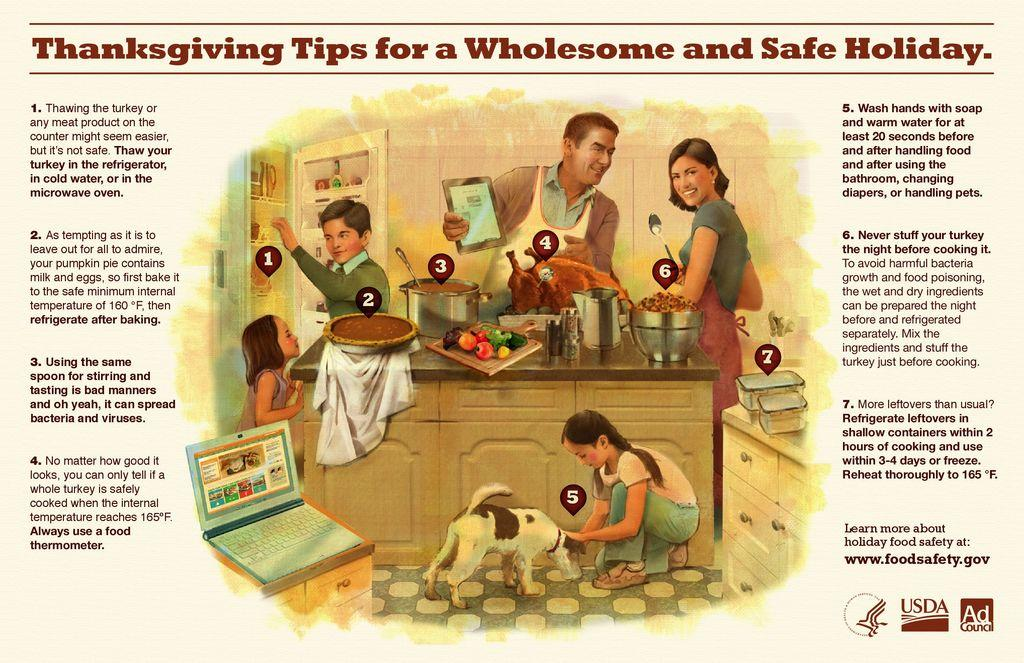<image>
Create a compact narrative representing the image presented. The poster shows a family preparing for a wholesome Thanksgiving dinner. 